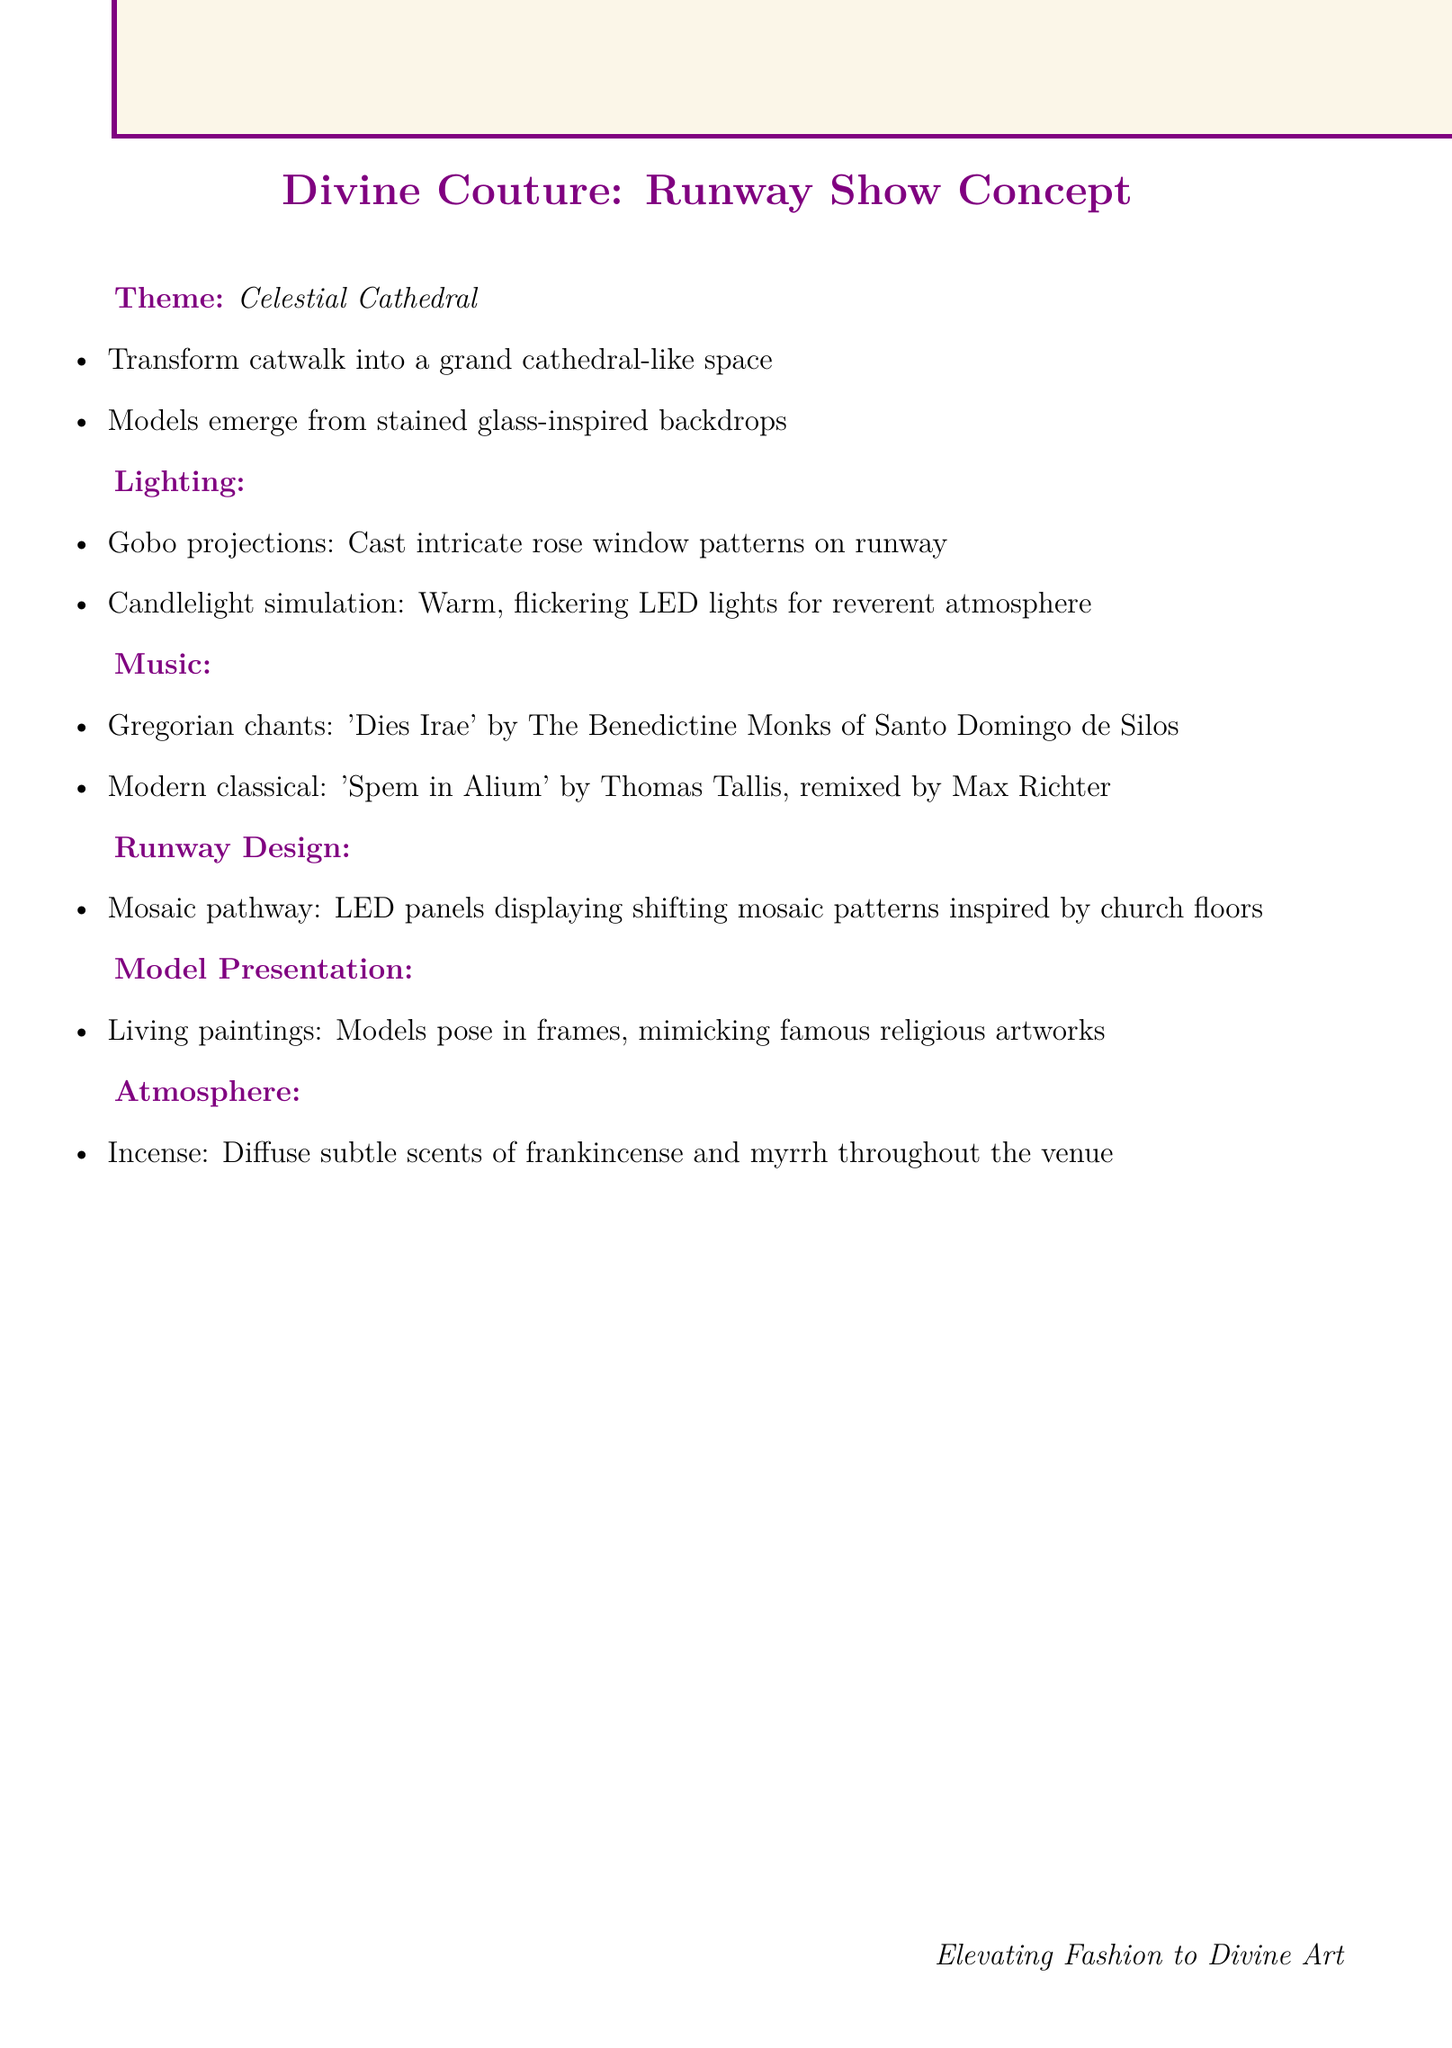What is the runway show theme? The theme is the central concept of the runway show as described in the document, referred to as "Celestial Cathedral."
Answer: Celestial Cathedral What kind of music is suggested for the show? The document lists specific genres and examples of music, including Gregorian chants and Modern classical.
Answer: Gregorian chants, Modern classical What visual element is mentioned for runway design? This covers a specific design feature that contributes to the overall aesthetic and is explicitly mentioned in the document.
Answer: Mosaic pathway What is an atmospheric element used in the venue? The document provides details about senses and ambiance to enhance the experience, one being the diffusion of scents throughout the venue.
Answer: Incense Which technique is used in lighting design? This asks for a specific method highlighted in the lighting ideas that creates visual effects on the runway.
Answer: Gobo projections How do models present themselves in the concept? The document describes a unique presentation style for models, referencing artistic inspiration from famous artworks.
Answer: Living paintings What is one suggested example of Gregorian chants? This question seeks a specific instance from the document that illustrates the music theme suggested.
Answer: 'Dies Irae' performed by The Benedictine Monks of Santo Domingo de Silos What kind of lighting creates a reverent atmosphere? This question focuses on the specific lighting concept noted in the document that enhances the sacred atmosphere.
Answer: Candlelight simulation 